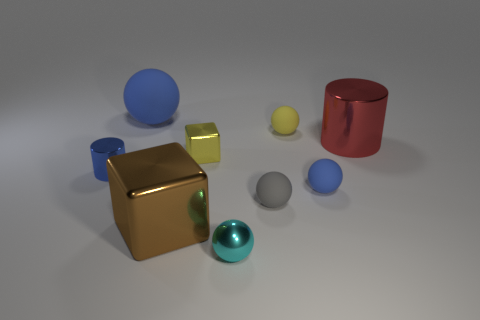Subtract all small shiny balls. How many balls are left? 4 Subtract all cylinders. How many objects are left? 7 Subtract all gray spheres. How many spheres are left? 4 Subtract 5 balls. How many balls are left? 0 Subtract all yellow blocks. Subtract all brown cylinders. How many blocks are left? 1 Subtract all red spheres. How many purple cylinders are left? 0 Subtract all yellow cylinders. Subtract all large objects. How many objects are left? 6 Add 2 tiny yellow shiny objects. How many tiny yellow shiny objects are left? 3 Add 4 blue rubber spheres. How many blue rubber spheres exist? 6 Add 1 metallic cylinders. How many objects exist? 10 